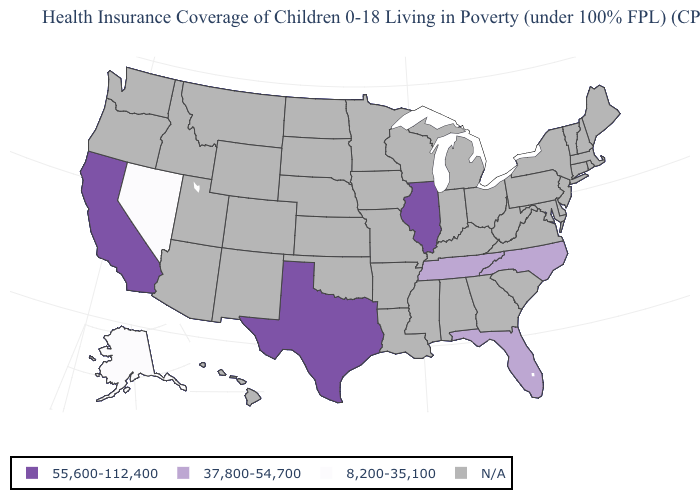What is the highest value in the USA?
Be succinct. 55,600-112,400. How many symbols are there in the legend?
Give a very brief answer. 4. Does Florida have the lowest value in the USA?
Give a very brief answer. No. What is the value of Alabama?
Keep it brief. N/A. What is the value of Wisconsin?
Answer briefly. N/A. Among the states that border North Carolina , which have the lowest value?
Answer briefly. Tennessee. Name the states that have a value in the range 55,600-112,400?
Quick response, please. California, Illinois, Texas. Which states have the lowest value in the USA?
Keep it brief. Alaska, Nevada. What is the value of Virginia?
Answer briefly. N/A. What is the value of Hawaii?
Give a very brief answer. N/A. 